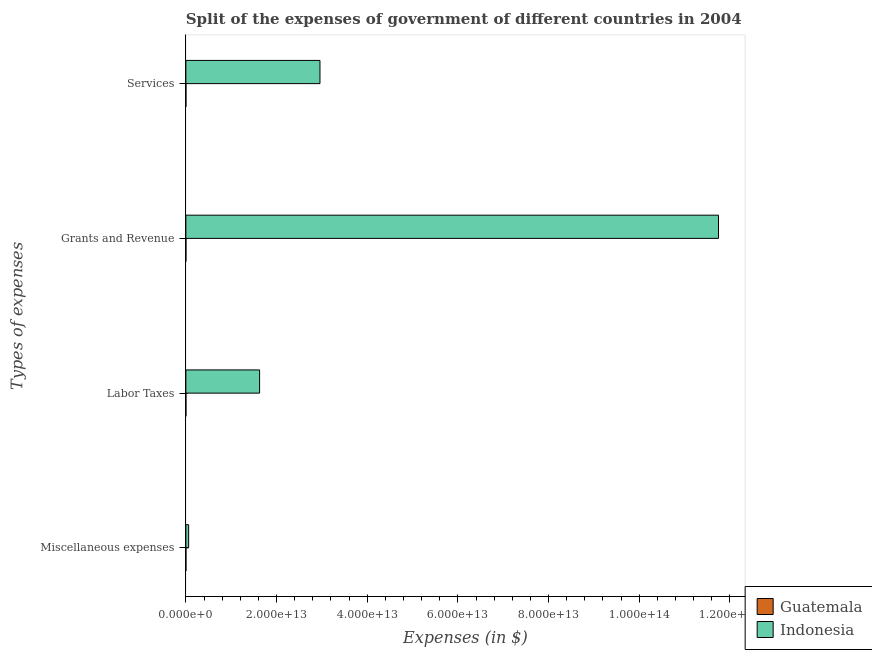How many different coloured bars are there?
Provide a succinct answer. 2. How many groups of bars are there?
Offer a very short reply. 4. Are the number of bars per tick equal to the number of legend labels?
Offer a terse response. Yes. What is the label of the 1st group of bars from the top?
Your response must be concise. Services. What is the amount spent on grants and revenue in Guatemala?
Make the answer very short. 8.48e+08. Across all countries, what is the maximum amount spent on miscellaneous expenses?
Offer a terse response. 6.11e+11. Across all countries, what is the minimum amount spent on grants and revenue?
Your response must be concise. 8.48e+08. In which country was the amount spent on services minimum?
Offer a very short reply. Guatemala. What is the total amount spent on labor taxes in the graph?
Ensure brevity in your answer.  1.63e+13. What is the difference between the amount spent on labor taxes in Guatemala and that in Indonesia?
Keep it short and to the point. -1.63e+13. What is the difference between the amount spent on grants and revenue in Indonesia and the amount spent on labor taxes in Guatemala?
Give a very brief answer. 1.17e+14. What is the average amount spent on labor taxes per country?
Ensure brevity in your answer.  8.13e+12. What is the difference between the amount spent on services and amount spent on miscellaneous expenses in Guatemala?
Make the answer very short. -7.83e+08. What is the ratio of the amount spent on services in Indonesia to that in Guatemala?
Give a very brief answer. 1.03e+04. Is the difference between the amount spent on grants and revenue in Indonesia and Guatemala greater than the difference between the amount spent on services in Indonesia and Guatemala?
Offer a very short reply. Yes. What is the difference between the highest and the second highest amount spent on grants and revenue?
Your answer should be very brief. 1.17e+14. What is the difference between the highest and the lowest amount spent on grants and revenue?
Provide a short and direct response. 1.17e+14. Is it the case that in every country, the sum of the amount spent on labor taxes and amount spent on grants and revenue is greater than the sum of amount spent on services and amount spent on miscellaneous expenses?
Offer a terse response. No. What does the 2nd bar from the top in Miscellaneous expenses represents?
Your answer should be compact. Guatemala. What does the 2nd bar from the bottom in Miscellaneous expenses represents?
Keep it short and to the point. Indonesia. Is it the case that in every country, the sum of the amount spent on miscellaneous expenses and amount spent on labor taxes is greater than the amount spent on grants and revenue?
Provide a short and direct response. No. How many bars are there?
Your answer should be compact. 8. Are all the bars in the graph horizontal?
Offer a terse response. Yes. How many countries are there in the graph?
Your response must be concise. 2. What is the difference between two consecutive major ticks on the X-axis?
Keep it short and to the point. 2.00e+13. Are the values on the major ticks of X-axis written in scientific E-notation?
Give a very brief answer. Yes. Does the graph contain any zero values?
Provide a short and direct response. No. How many legend labels are there?
Your response must be concise. 2. What is the title of the graph?
Offer a very short reply. Split of the expenses of government of different countries in 2004. Does "Latin America(all income levels)" appear as one of the legend labels in the graph?
Your answer should be compact. No. What is the label or title of the X-axis?
Your response must be concise. Expenses (in $). What is the label or title of the Y-axis?
Offer a very short reply. Types of expenses. What is the Expenses (in $) in Guatemala in Miscellaneous expenses?
Provide a succinct answer. 3.67e+09. What is the Expenses (in $) of Indonesia in Miscellaneous expenses?
Give a very brief answer. 6.11e+11. What is the Expenses (in $) of Guatemala in Labor Taxes?
Your answer should be very brief. 2.97e+08. What is the Expenses (in $) in Indonesia in Labor Taxes?
Ensure brevity in your answer.  1.63e+13. What is the Expenses (in $) in Guatemala in Grants and Revenue?
Provide a short and direct response. 8.48e+08. What is the Expenses (in $) of Indonesia in Grants and Revenue?
Your response must be concise. 1.17e+14. What is the Expenses (in $) in Guatemala in Services?
Your response must be concise. 2.88e+09. What is the Expenses (in $) of Indonesia in Services?
Offer a terse response. 2.96e+13. Across all Types of expenses, what is the maximum Expenses (in $) of Guatemala?
Give a very brief answer. 3.67e+09. Across all Types of expenses, what is the maximum Expenses (in $) of Indonesia?
Give a very brief answer. 1.17e+14. Across all Types of expenses, what is the minimum Expenses (in $) of Guatemala?
Provide a succinct answer. 2.97e+08. Across all Types of expenses, what is the minimum Expenses (in $) in Indonesia?
Provide a succinct answer. 6.11e+11. What is the total Expenses (in $) in Guatemala in the graph?
Your answer should be compact. 7.70e+09. What is the total Expenses (in $) of Indonesia in the graph?
Keep it short and to the point. 1.64e+14. What is the difference between the Expenses (in $) of Guatemala in Miscellaneous expenses and that in Labor Taxes?
Provide a succinct answer. 3.37e+09. What is the difference between the Expenses (in $) of Indonesia in Miscellaneous expenses and that in Labor Taxes?
Your answer should be compact. -1.56e+13. What is the difference between the Expenses (in $) in Guatemala in Miscellaneous expenses and that in Grants and Revenue?
Offer a terse response. 2.82e+09. What is the difference between the Expenses (in $) in Indonesia in Miscellaneous expenses and that in Grants and Revenue?
Offer a terse response. -1.17e+14. What is the difference between the Expenses (in $) of Guatemala in Miscellaneous expenses and that in Services?
Your response must be concise. 7.83e+08. What is the difference between the Expenses (in $) in Indonesia in Miscellaneous expenses and that in Services?
Ensure brevity in your answer.  -2.90e+13. What is the difference between the Expenses (in $) in Guatemala in Labor Taxes and that in Grants and Revenue?
Provide a succinct answer. -5.51e+08. What is the difference between the Expenses (in $) in Indonesia in Labor Taxes and that in Grants and Revenue?
Keep it short and to the point. -1.01e+14. What is the difference between the Expenses (in $) in Guatemala in Labor Taxes and that in Services?
Offer a terse response. -2.59e+09. What is the difference between the Expenses (in $) of Indonesia in Labor Taxes and that in Services?
Give a very brief answer. -1.33e+13. What is the difference between the Expenses (in $) of Guatemala in Grants and Revenue and that in Services?
Make the answer very short. -2.04e+09. What is the difference between the Expenses (in $) in Indonesia in Grants and Revenue and that in Services?
Provide a succinct answer. 8.79e+13. What is the difference between the Expenses (in $) of Guatemala in Miscellaneous expenses and the Expenses (in $) of Indonesia in Labor Taxes?
Provide a short and direct response. -1.63e+13. What is the difference between the Expenses (in $) in Guatemala in Miscellaneous expenses and the Expenses (in $) in Indonesia in Grants and Revenue?
Your answer should be very brief. -1.17e+14. What is the difference between the Expenses (in $) in Guatemala in Miscellaneous expenses and the Expenses (in $) in Indonesia in Services?
Provide a succinct answer. -2.96e+13. What is the difference between the Expenses (in $) in Guatemala in Labor Taxes and the Expenses (in $) in Indonesia in Grants and Revenue?
Your answer should be compact. -1.17e+14. What is the difference between the Expenses (in $) of Guatemala in Labor Taxes and the Expenses (in $) of Indonesia in Services?
Make the answer very short. -2.96e+13. What is the difference between the Expenses (in $) of Guatemala in Grants and Revenue and the Expenses (in $) of Indonesia in Services?
Offer a terse response. -2.96e+13. What is the average Expenses (in $) of Guatemala per Types of expenses?
Your answer should be compact. 1.92e+09. What is the average Expenses (in $) of Indonesia per Types of expenses?
Offer a very short reply. 4.10e+13. What is the difference between the Expenses (in $) of Guatemala and Expenses (in $) of Indonesia in Miscellaneous expenses?
Your response must be concise. -6.07e+11. What is the difference between the Expenses (in $) in Guatemala and Expenses (in $) in Indonesia in Labor Taxes?
Your answer should be compact. -1.63e+13. What is the difference between the Expenses (in $) of Guatemala and Expenses (in $) of Indonesia in Grants and Revenue?
Offer a very short reply. -1.17e+14. What is the difference between the Expenses (in $) of Guatemala and Expenses (in $) of Indonesia in Services?
Give a very brief answer. -2.96e+13. What is the ratio of the Expenses (in $) in Guatemala in Miscellaneous expenses to that in Labor Taxes?
Your answer should be very brief. 12.33. What is the ratio of the Expenses (in $) in Indonesia in Miscellaneous expenses to that in Labor Taxes?
Offer a very short reply. 0.04. What is the ratio of the Expenses (in $) in Guatemala in Miscellaneous expenses to that in Grants and Revenue?
Provide a succinct answer. 4.32. What is the ratio of the Expenses (in $) of Indonesia in Miscellaneous expenses to that in Grants and Revenue?
Your answer should be very brief. 0.01. What is the ratio of the Expenses (in $) of Guatemala in Miscellaneous expenses to that in Services?
Ensure brevity in your answer.  1.27. What is the ratio of the Expenses (in $) in Indonesia in Miscellaneous expenses to that in Services?
Ensure brevity in your answer.  0.02. What is the ratio of the Expenses (in $) in Guatemala in Labor Taxes to that in Grants and Revenue?
Your response must be concise. 0.35. What is the ratio of the Expenses (in $) of Indonesia in Labor Taxes to that in Grants and Revenue?
Ensure brevity in your answer.  0.14. What is the ratio of the Expenses (in $) in Guatemala in Labor Taxes to that in Services?
Provide a short and direct response. 0.1. What is the ratio of the Expenses (in $) of Indonesia in Labor Taxes to that in Services?
Provide a short and direct response. 0.55. What is the ratio of the Expenses (in $) in Guatemala in Grants and Revenue to that in Services?
Your response must be concise. 0.29. What is the ratio of the Expenses (in $) in Indonesia in Grants and Revenue to that in Services?
Provide a short and direct response. 3.97. What is the difference between the highest and the second highest Expenses (in $) of Guatemala?
Give a very brief answer. 7.83e+08. What is the difference between the highest and the second highest Expenses (in $) of Indonesia?
Make the answer very short. 8.79e+13. What is the difference between the highest and the lowest Expenses (in $) of Guatemala?
Make the answer very short. 3.37e+09. What is the difference between the highest and the lowest Expenses (in $) of Indonesia?
Make the answer very short. 1.17e+14. 